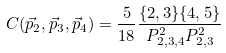Convert formula to latex. <formula><loc_0><loc_0><loc_500><loc_500>C ( \vec { p } _ { 2 } , \vec { p } _ { 3 } , \vec { p } _ { 4 } ) = \frac { 5 } { 1 8 } \frac { \{ 2 , 3 \} \{ 4 , 5 \} } { P _ { 2 , 3 , 4 } ^ { 2 } P _ { 2 , 3 } ^ { 2 } }</formula> 